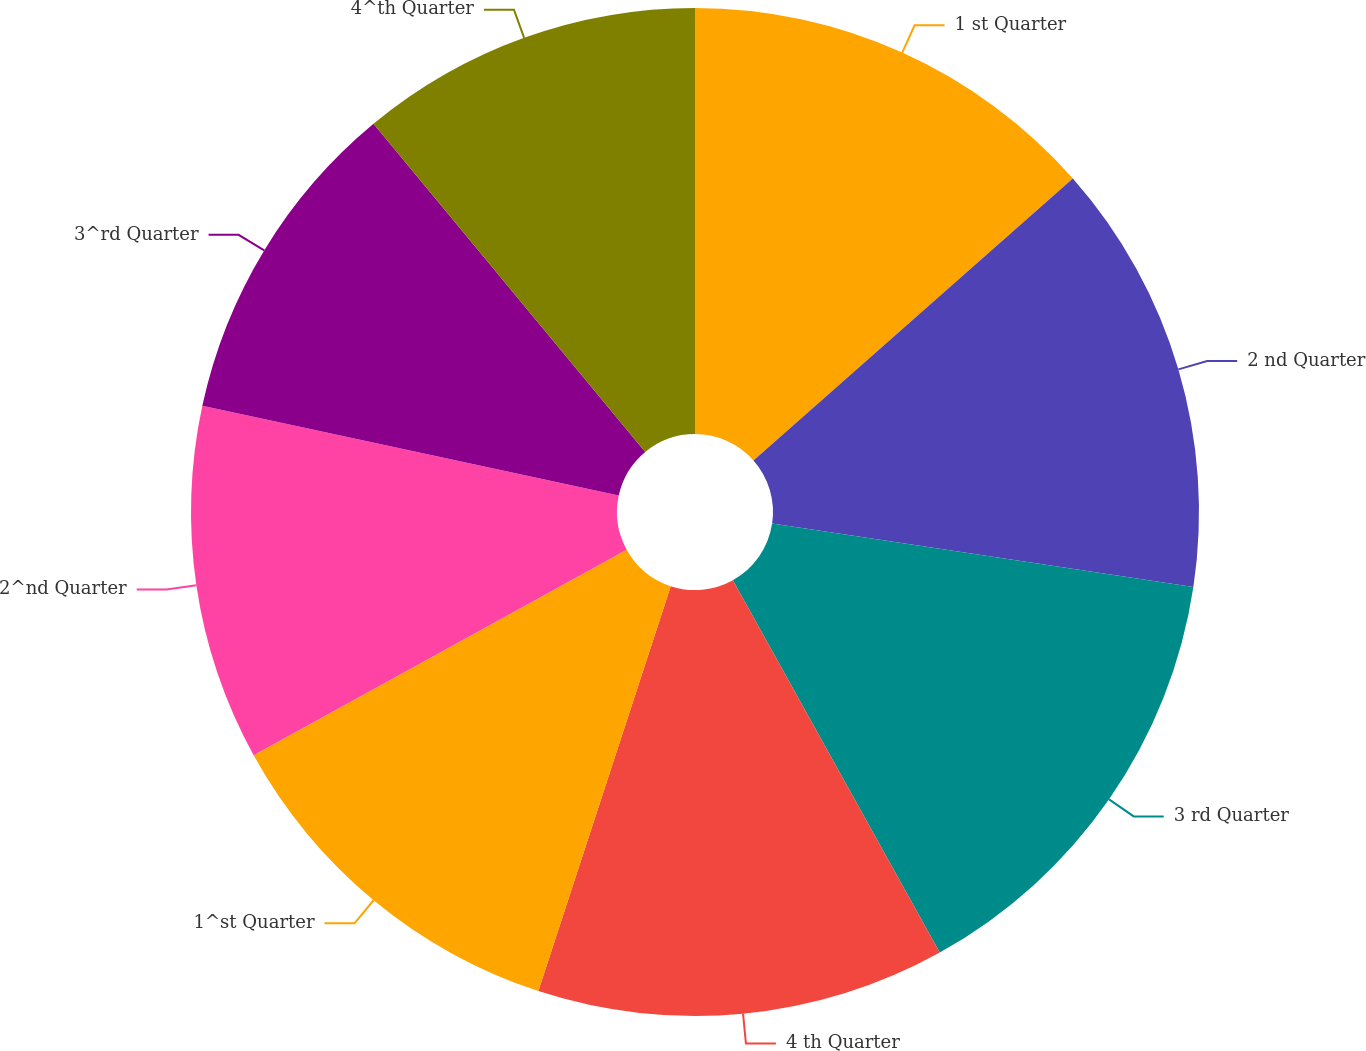Convert chart. <chart><loc_0><loc_0><loc_500><loc_500><pie_chart><fcel>1 st Quarter<fcel>2 nd Quarter<fcel>3 rd Quarter<fcel>4 th Quarter<fcel>1^st Quarter<fcel>2^nd Quarter<fcel>3^rd Quarter<fcel>4^th Quarter<nl><fcel>13.49%<fcel>13.89%<fcel>14.55%<fcel>13.1%<fcel>11.95%<fcel>11.4%<fcel>10.61%<fcel>11.01%<nl></chart> 